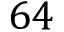Convert formula to latex. <formula><loc_0><loc_0><loc_500><loc_500>6 4</formula> 